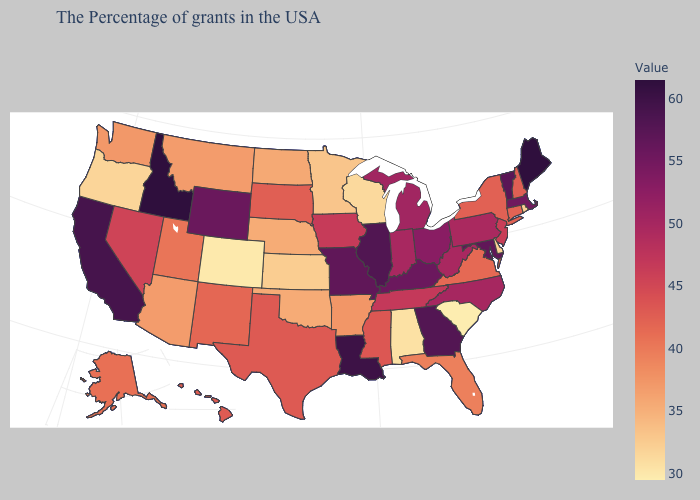Which states have the highest value in the USA?
Quick response, please. Maine, Idaho. Does Illinois have the highest value in the MidWest?
Be succinct. Yes. Among the states that border Michigan , which have the lowest value?
Quick response, please. Wisconsin. Does Indiana have a lower value than Wyoming?
Short answer required. Yes. Which states have the lowest value in the Northeast?
Answer briefly. Rhode Island. Does Maine have the highest value in the USA?
Quick response, please. Yes. Does Ohio have a lower value than Delaware?
Be succinct. No. Does Ohio have a lower value than Missouri?
Short answer required. Yes. Which states have the highest value in the USA?
Short answer required. Maine, Idaho. 